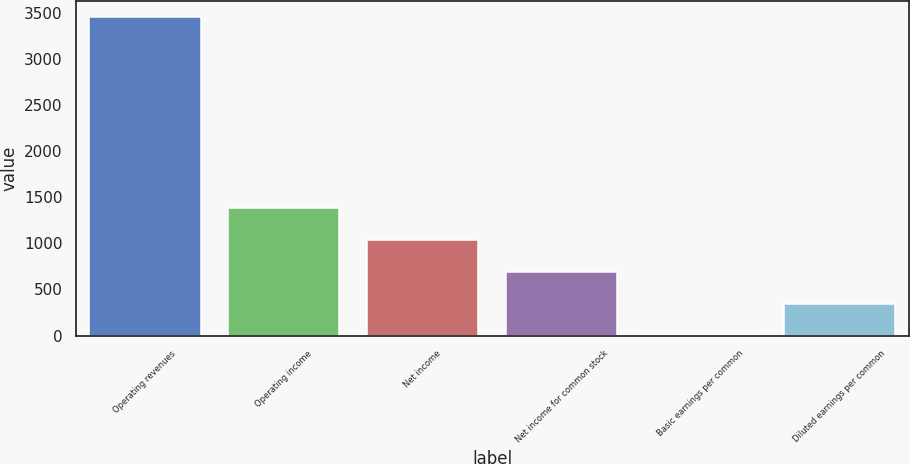Convert chart. <chart><loc_0><loc_0><loc_500><loc_500><bar_chart><fcel>Operating revenues<fcel>Operating income<fcel>Net income<fcel>Net income for common stock<fcel>Basic earnings per common<fcel>Diluted earnings per common<nl><fcel>3462<fcel>1385.28<fcel>1039.16<fcel>693.04<fcel>0.8<fcel>346.92<nl></chart> 